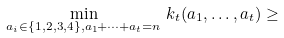<formula> <loc_0><loc_0><loc_500><loc_500>\min _ { a _ { i } \in \{ 1 , 2 , 3 , 4 \} , a _ { 1 } + \dots + a _ { t } = n } \, k _ { t } ( a _ { 1 } , \dots , a _ { t } ) \geq</formula> 